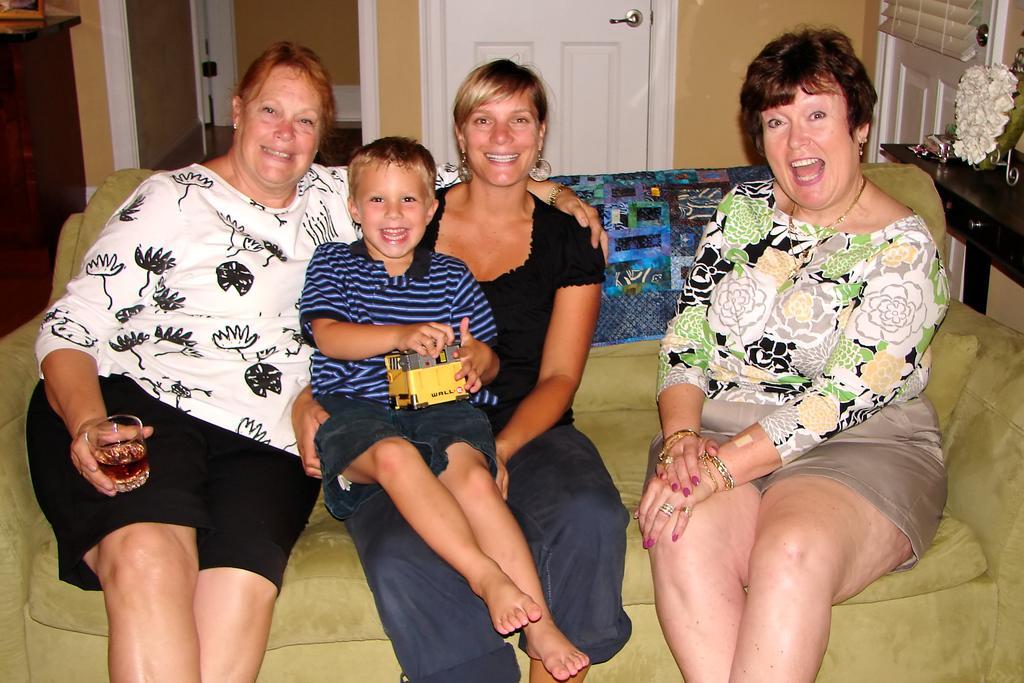Please provide a concise description of this image. In this image I can see five person sitting on the couch and the couch is in green color, at left I can see few objects on the table, and the table is in brown color. At the back I can see door in white color and wall in brown color. 